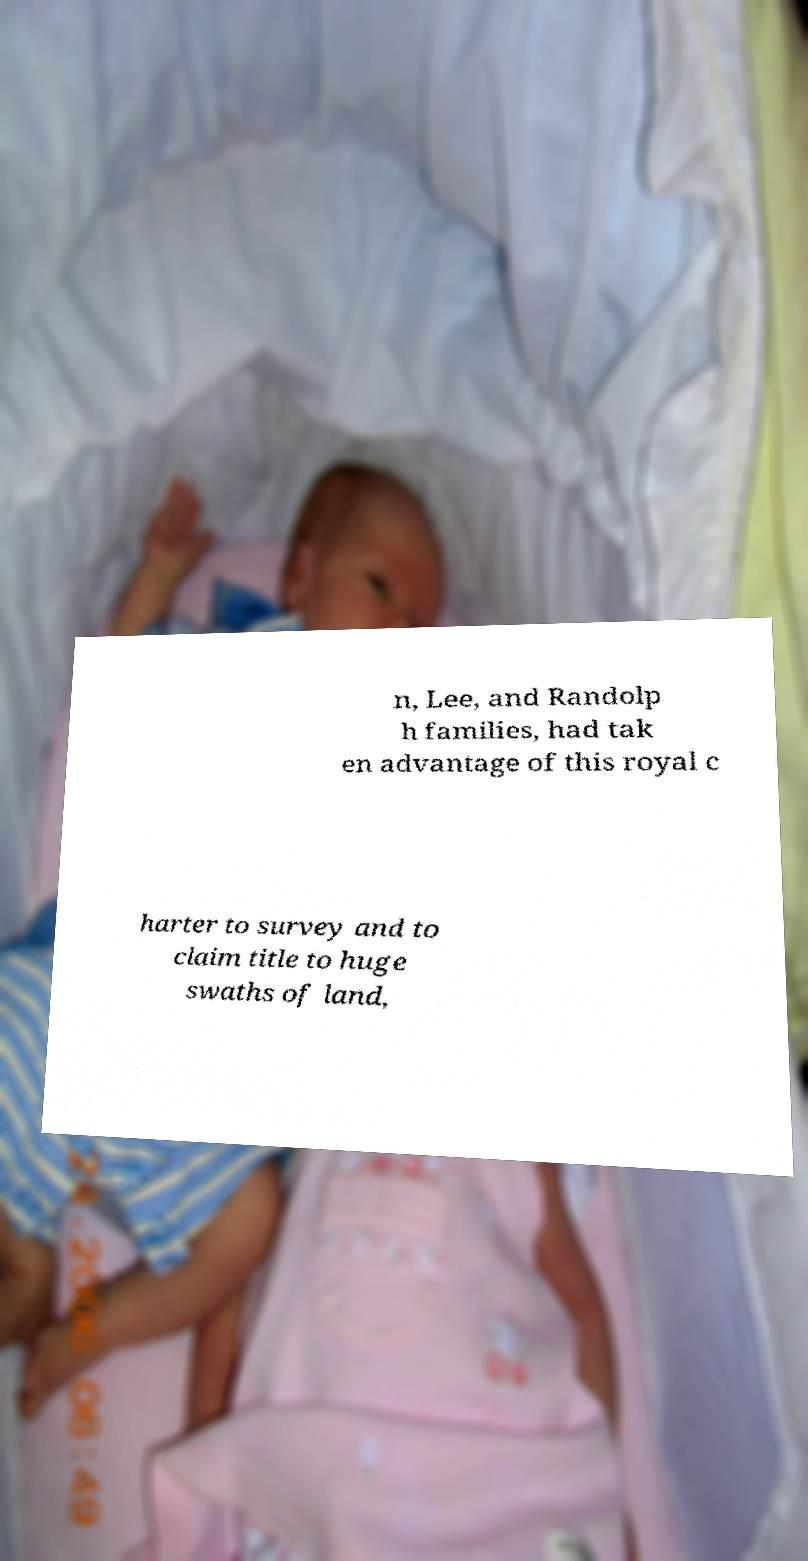Please identify and transcribe the text found in this image. n, Lee, and Randolp h families, had tak en advantage of this royal c harter to survey and to claim title to huge swaths of land, 